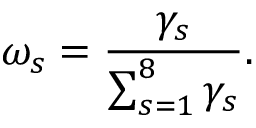<formula> <loc_0><loc_0><loc_500><loc_500>\omega _ { s } = \frac { \gamma _ { s } } { \sum _ { s = 1 } ^ { 8 } \gamma _ { s } } .</formula> 